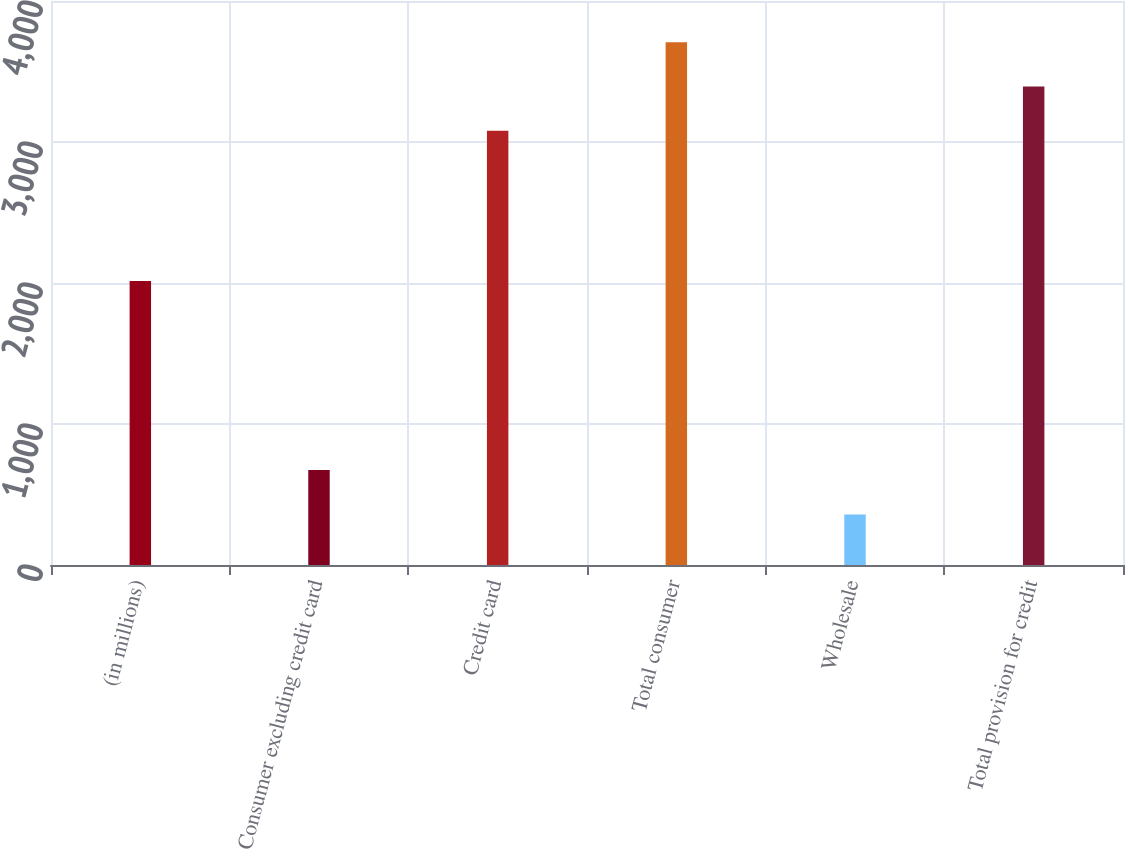Convert chart to OTSL. <chart><loc_0><loc_0><loc_500><loc_500><bar_chart><fcel>(in millions)<fcel>Consumer excluding credit card<fcel>Credit card<fcel>Total consumer<fcel>Wholesale<fcel>Total provision for credit<nl><fcel>2014<fcel>672.9<fcel>3079<fcel>3706.8<fcel>359<fcel>3392.9<nl></chart> 